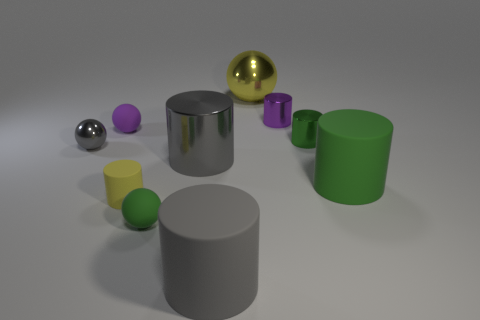There is a small purple object that is the same shape as the big yellow metallic thing; what is it made of?
Give a very brief answer. Rubber. There is a green thing left of the small purple shiny cylinder; what is its shape?
Offer a terse response. Sphere. Are there any small purple things that have the same material as the big yellow sphere?
Ensure brevity in your answer.  Yes. Is the purple metallic cylinder the same size as the yellow rubber cylinder?
Offer a terse response. Yes. How many cubes are either big gray objects or tiny green things?
Offer a terse response. 0. There is a tiny cylinder that is the same color as the big sphere; what material is it?
Ensure brevity in your answer.  Rubber. How many small green metal objects are the same shape as the tiny yellow thing?
Your response must be concise. 1. Is the number of tiny purple cylinders on the right side of the big green matte cylinder greater than the number of tiny things that are on the left side of the yellow metal object?
Make the answer very short. No. Does the big rubber cylinder that is left of the green matte cylinder have the same color as the big metal cylinder?
Offer a terse response. Yes. How big is the purple shiny cylinder?
Keep it short and to the point. Small. 